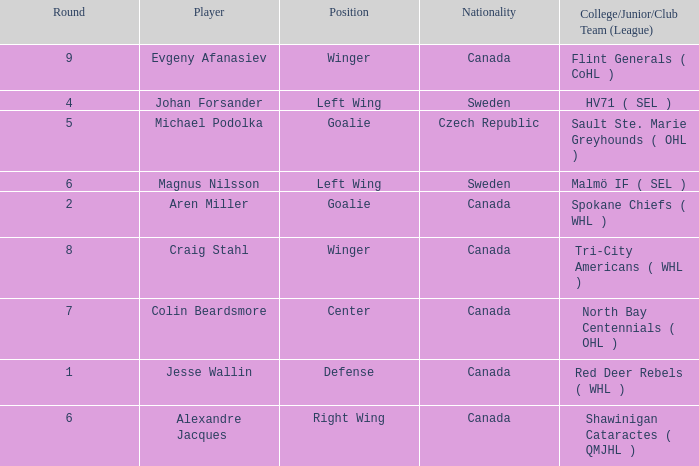What is the School/Junior/Club Group (Class) that has a Nationality of canada, and a Place of goalie? Spokane Chiefs ( WHL ). 